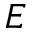<formula> <loc_0><loc_0><loc_500><loc_500>E</formula> 